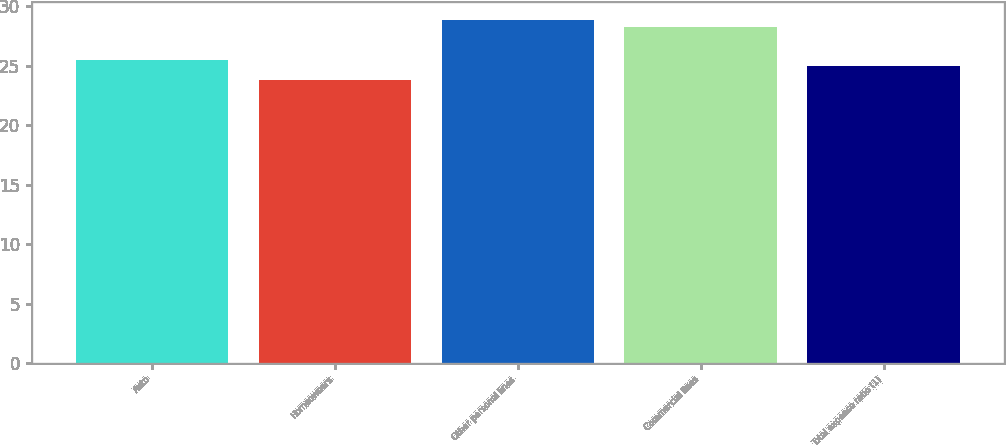<chart> <loc_0><loc_0><loc_500><loc_500><bar_chart><fcel>Auto<fcel>Homeowners<fcel>Other personal lines<fcel>Commercial lines<fcel>Total expense ratio (1)<nl><fcel>25.51<fcel>23.8<fcel>28.9<fcel>28.3<fcel>25<nl></chart> 